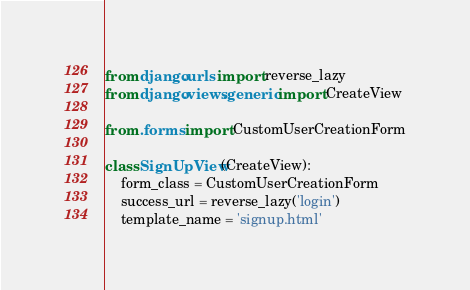Convert code to text. <code><loc_0><loc_0><loc_500><loc_500><_Python_>from django.urls import reverse_lazy
from django.views.generic import CreateView

from .forms import CustomUserCreationForm

class SignUpView(CreateView):
    form_class = CustomUserCreationForm
    success_url = reverse_lazy('login')
    template_name = 'signup.html'
</code> 